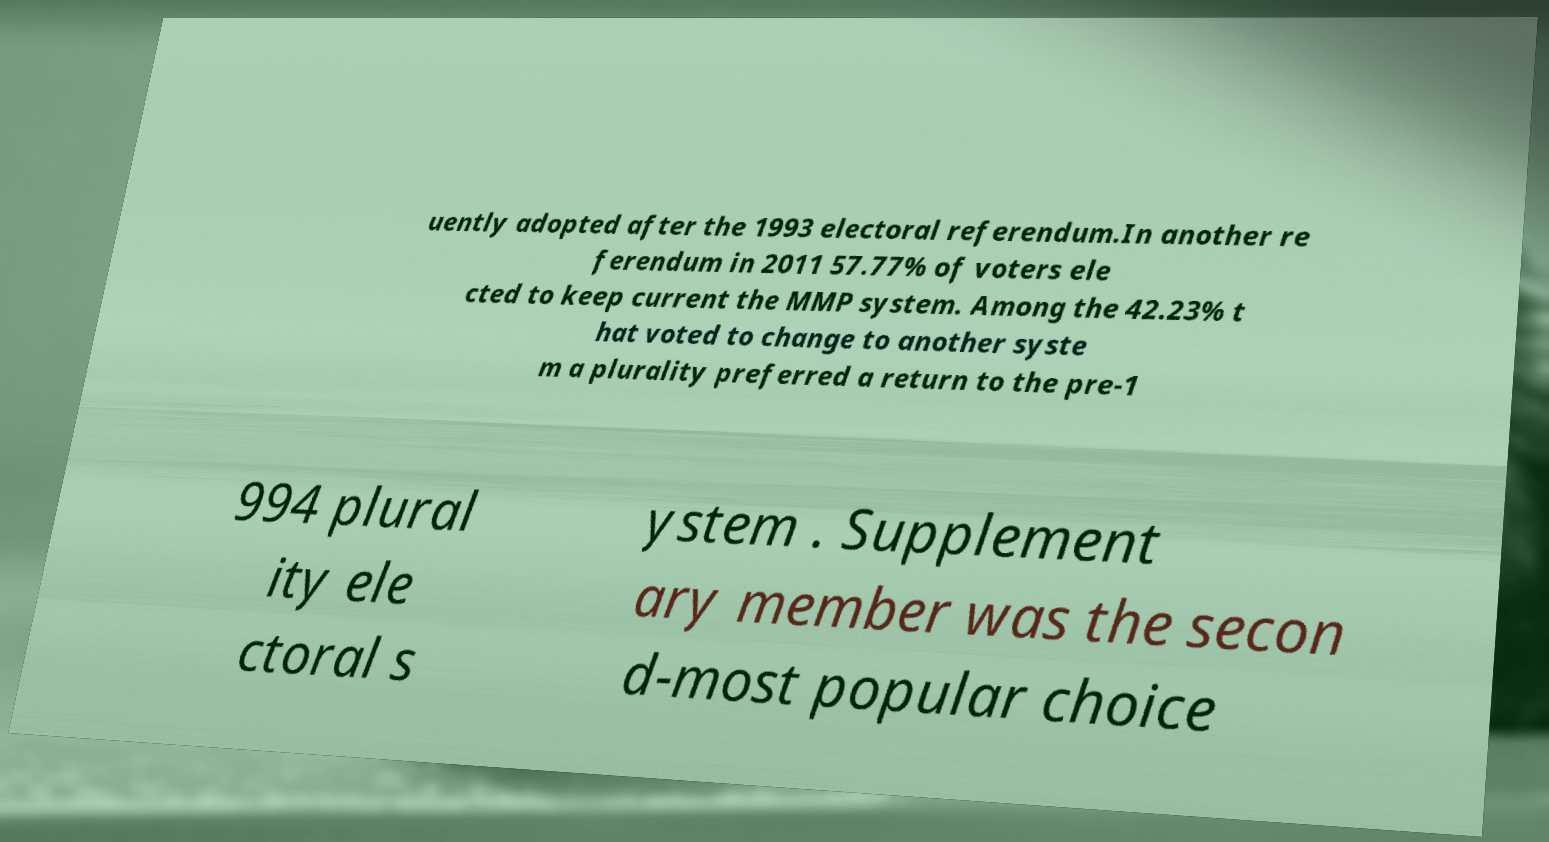Please read and relay the text visible in this image. What does it say? uently adopted after the 1993 electoral referendum.In another re ferendum in 2011 57.77% of voters ele cted to keep current the MMP system. Among the 42.23% t hat voted to change to another syste m a plurality preferred a return to the pre-1 994 plural ity ele ctoral s ystem . Supplement ary member was the secon d-most popular choice 